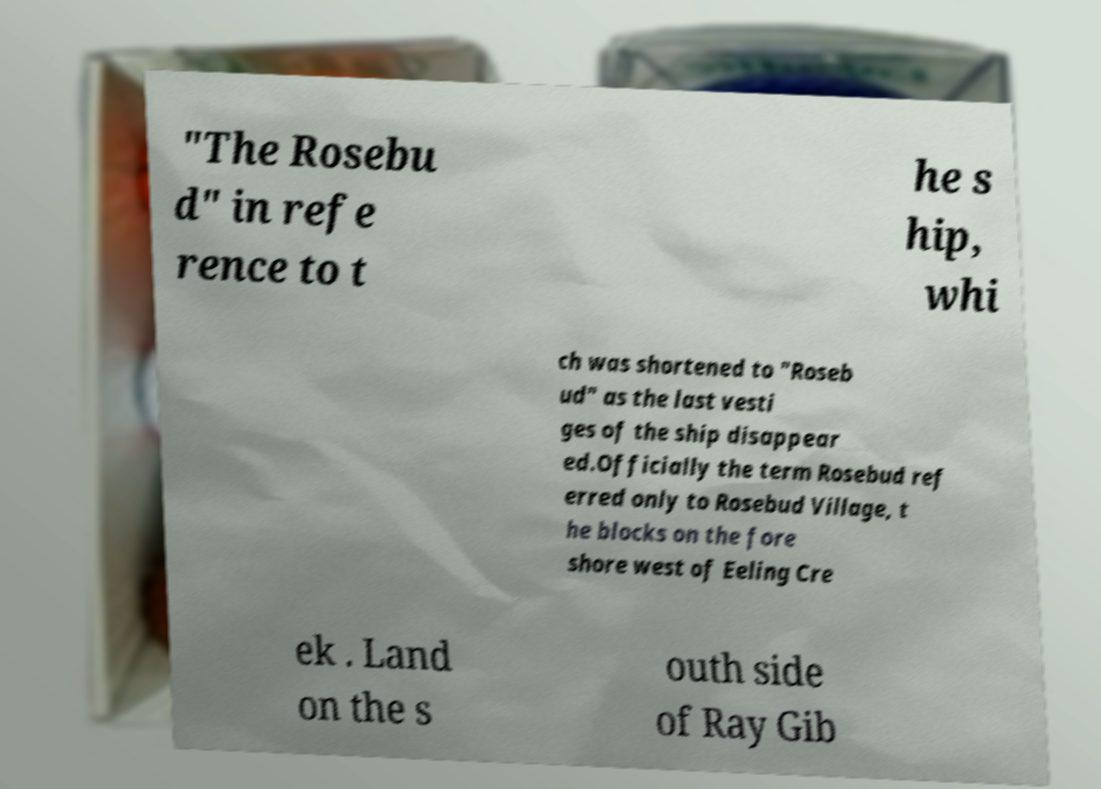Could you extract and type out the text from this image? "The Rosebu d" in refe rence to t he s hip, whi ch was shortened to "Roseb ud" as the last vesti ges of the ship disappear ed.Officially the term Rosebud ref erred only to Rosebud Village, t he blocks on the fore shore west of Eeling Cre ek . Land on the s outh side of Ray Gib 